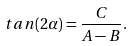Convert formula to latex. <formula><loc_0><loc_0><loc_500><loc_500>t a n ( 2 \alpha ) = \frac { C } { A - B } .</formula> 